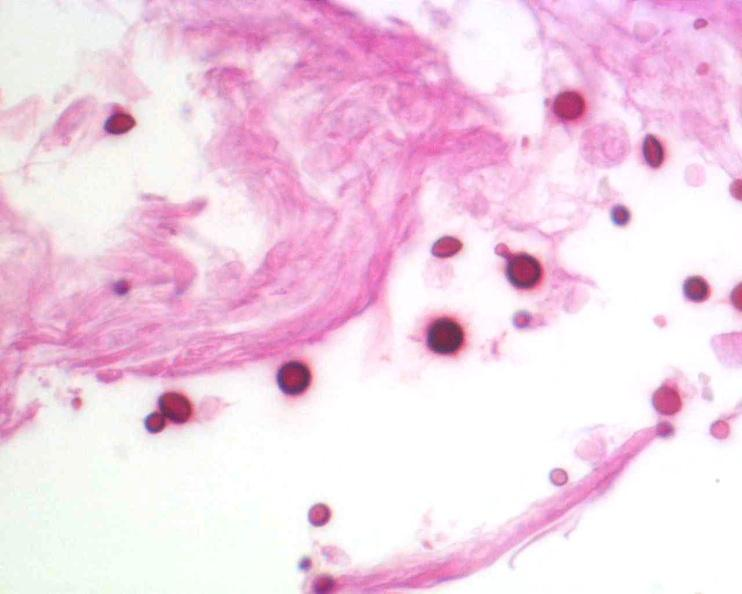does brain, cryptococcal meningitis, pas stain?
Answer the question using a single word or phrase. Yes 